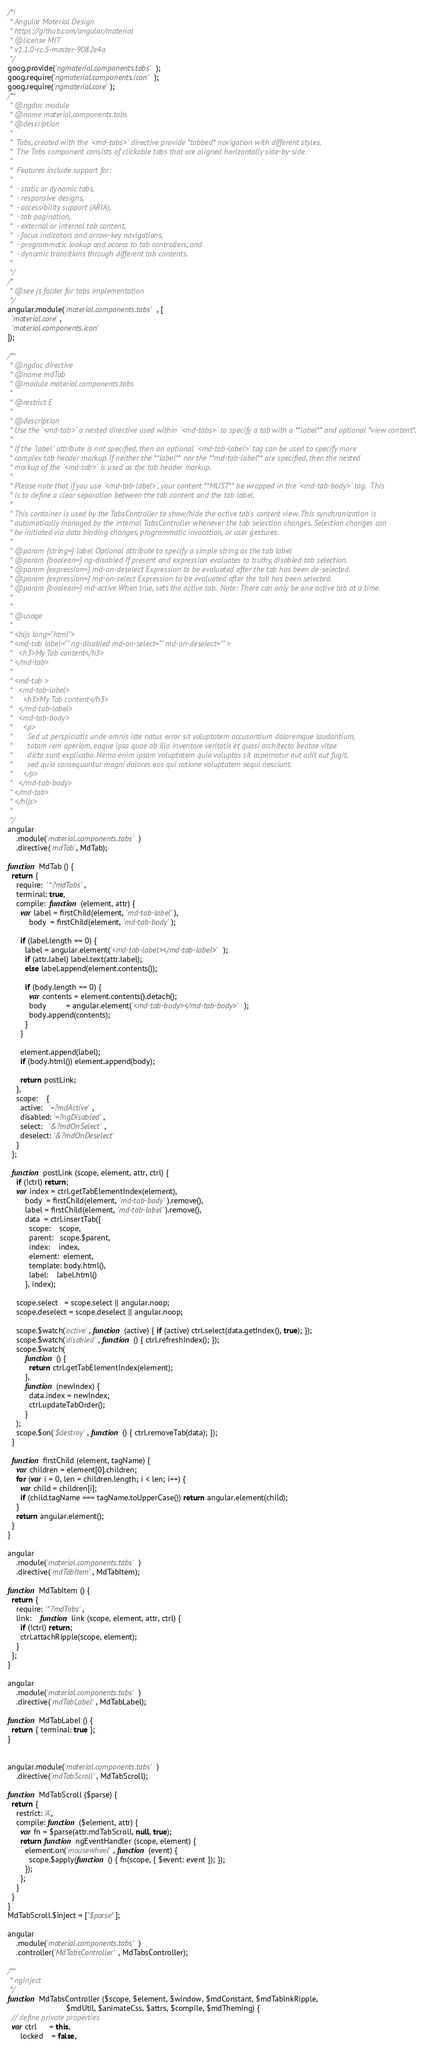Convert code to text. <code><loc_0><loc_0><loc_500><loc_500><_JavaScript_>/*!
 * Angular Material Design
 * https://github.com/angular/material
 * @license MIT
 * v1.1.0-rc.5-master-9082e4a
 */
goog.provide('ngmaterial.components.tabs');
goog.require('ngmaterial.components.icon');
goog.require('ngmaterial.core');
/**
 * @ngdoc module
 * @name material.components.tabs
 * @description
 *
 *  Tabs, created with the `<md-tabs>` directive provide *tabbed* navigation with different styles.
 *  The Tabs component consists of clickable tabs that are aligned horizontally side-by-side.
 *
 *  Features include support for:
 *
 *  - static or dynamic tabs,
 *  - responsive designs,
 *  - accessibility support (ARIA),
 *  - tab pagination,
 *  - external or internal tab content,
 *  - focus indicators and arrow-key navigations,
 *  - programmatic lookup and access to tab controllers, and
 *  - dynamic transitions through different tab contents.
 *
 */
/*
 * @see js folder for tabs implementation
 */
angular.module('material.components.tabs', [
  'material.core',
  'material.components.icon'
]);

/**
 * @ngdoc directive
 * @name mdTab
 * @module material.components.tabs
 *
 * @restrict E
 *
 * @description
 * Use the `<md-tab>` a nested directive used within `<md-tabs>` to specify a tab with a **label** and optional *view content*.
 *
 * If the `label` attribute is not specified, then an optional `<md-tab-label>` tag can be used to specify more
 * complex tab header markup. If neither the **label** nor the **md-tab-label** are specified, then the nested
 * markup of the `<md-tab>` is used as the tab header markup.
 *
 * Please note that if you use `<md-tab-label>`, your content **MUST** be wrapped in the `<md-tab-body>` tag.  This
 * is to define a clear separation between the tab content and the tab label.
 *
 * This container is used by the TabsController to show/hide the active tab's content view. This synchronization is
 * automatically managed by the internal TabsController whenever the tab selection changes. Selection changes can
 * be initiated via data binding changes, programmatic invocation, or user gestures.
 *
 * @param {string=} label Optional attribute to specify a simple string as the tab label
 * @param {boolean=} ng-disabled If present and expression evaluates to truthy, disabled tab selection.
 * @param {expression=} md-on-deselect Expression to be evaluated after the tab has been de-selected.
 * @param {expression=} md-on-select Expression to be evaluated after the tab has been selected.
 * @param {boolean=} md-active When true, sets the active tab.  Note: There can only be one active tab at a time.
 *
 *
 * @usage
 *
 * <hljs lang="html">
 * <md-tab label="" ng-disabled md-on-select="" md-on-deselect="" >
 *   <h3>My Tab content</h3>
 * </md-tab>
 *
 * <md-tab >
 *   <md-tab-label>
 *     <h3>My Tab content</h3>
 *   </md-tab-label>
 *   <md-tab-body>
 *     <p>
 *       Sed ut perspiciatis unde omnis iste natus error sit voluptatem accusantium doloremque laudantium,
 *       totam rem aperiam, eaque ipsa quae ab illo inventore veritatis et quasi architecto beatae vitae
 *       dicta sunt explicabo. Nemo enim ipsam voluptatem quia voluptas sit aspernatur aut odit aut fugit,
 *       sed quia consequuntur magni dolores eos qui ratione voluptatem sequi nesciunt.
 *     </p>
 *   </md-tab-body>
 * </md-tab>
 * </hljs>
 *
 */
angular
    .module('material.components.tabs')
    .directive('mdTab', MdTab);

function MdTab () {
  return {
    require:  '^?mdTabs',
    terminal: true,
    compile:  function (element, attr) {
      var label = firstChild(element, 'md-tab-label'),
          body  = firstChild(element, 'md-tab-body');

      if (label.length == 0) {
        label = angular.element('<md-tab-label></md-tab-label>');
        if (attr.label) label.text(attr.label);
        else label.append(element.contents());

        if (body.length == 0) {
          var contents = element.contents().detach();
          body         = angular.element('<md-tab-body></md-tab-body>');
          body.append(contents);
        }
      }

      element.append(label);
      if (body.html()) element.append(body);

      return postLink;
    },
    scope:    {
      active:   '=?mdActive',
      disabled: '=?ngDisabled',
      select:   '&?mdOnSelect',
      deselect: '&?mdOnDeselect'
    }
  };

  function postLink (scope, element, attr, ctrl) {
    if (!ctrl) return;
    var index = ctrl.getTabElementIndex(element),
        body  = firstChild(element, 'md-tab-body').remove(),
        label = firstChild(element, 'md-tab-label').remove(),
        data  = ctrl.insertTab({
          scope:    scope,
          parent:   scope.$parent,
          index:    index,
          element:  element,
          template: body.html(),
          label:    label.html()
        }, index);

    scope.select   = scope.select || angular.noop;
    scope.deselect = scope.deselect || angular.noop;

    scope.$watch('active', function (active) { if (active) ctrl.select(data.getIndex(), true); });
    scope.$watch('disabled', function () { ctrl.refreshIndex(); });
    scope.$watch(
        function () {
          return ctrl.getTabElementIndex(element);
        },
        function (newIndex) {
          data.index = newIndex;
          ctrl.updateTabOrder();
        }
    );
    scope.$on('$destroy', function () { ctrl.removeTab(data); });
  }

  function firstChild (element, tagName) {
    var children = element[0].children;
    for (var i = 0, len = children.length; i < len; i++) {
      var child = children[i];
      if (child.tagName === tagName.toUpperCase()) return angular.element(child);
    }
    return angular.element();
  }
}

angular
    .module('material.components.tabs')
    .directive('mdTabItem', MdTabItem);

function MdTabItem () {
  return {
    require: '^?mdTabs',
    link:    function link (scope, element, attr, ctrl) {
      if (!ctrl) return;
      ctrl.attachRipple(scope, element);
    }
  };
}

angular
    .module('material.components.tabs')
    .directive('mdTabLabel', MdTabLabel);

function MdTabLabel () {
  return { terminal: true };
}


angular.module('material.components.tabs')
    .directive('mdTabScroll', MdTabScroll);

function MdTabScroll ($parse) {
  return {
    restrict: 'A',
    compile: function ($element, attr) {
      var fn = $parse(attr.mdTabScroll, null, true);
      return function ngEventHandler (scope, element) {
        element.on('mousewheel', function (event) {
          scope.$apply(function () { fn(scope, { $event: event }); });
        });
      };
    }
  }
}
MdTabScroll.$inject = ["$parse"];

angular
    .module('material.components.tabs')
    .controller('MdTabsController', MdTabsController);

/**
 * ngInject
 */
function MdTabsController ($scope, $element, $window, $mdConstant, $mdTabInkRipple,
                           $mdUtil, $animateCss, $attrs, $compile, $mdTheming) {
  // define private properties
  var ctrl      = this,
      locked    = false,</code> 